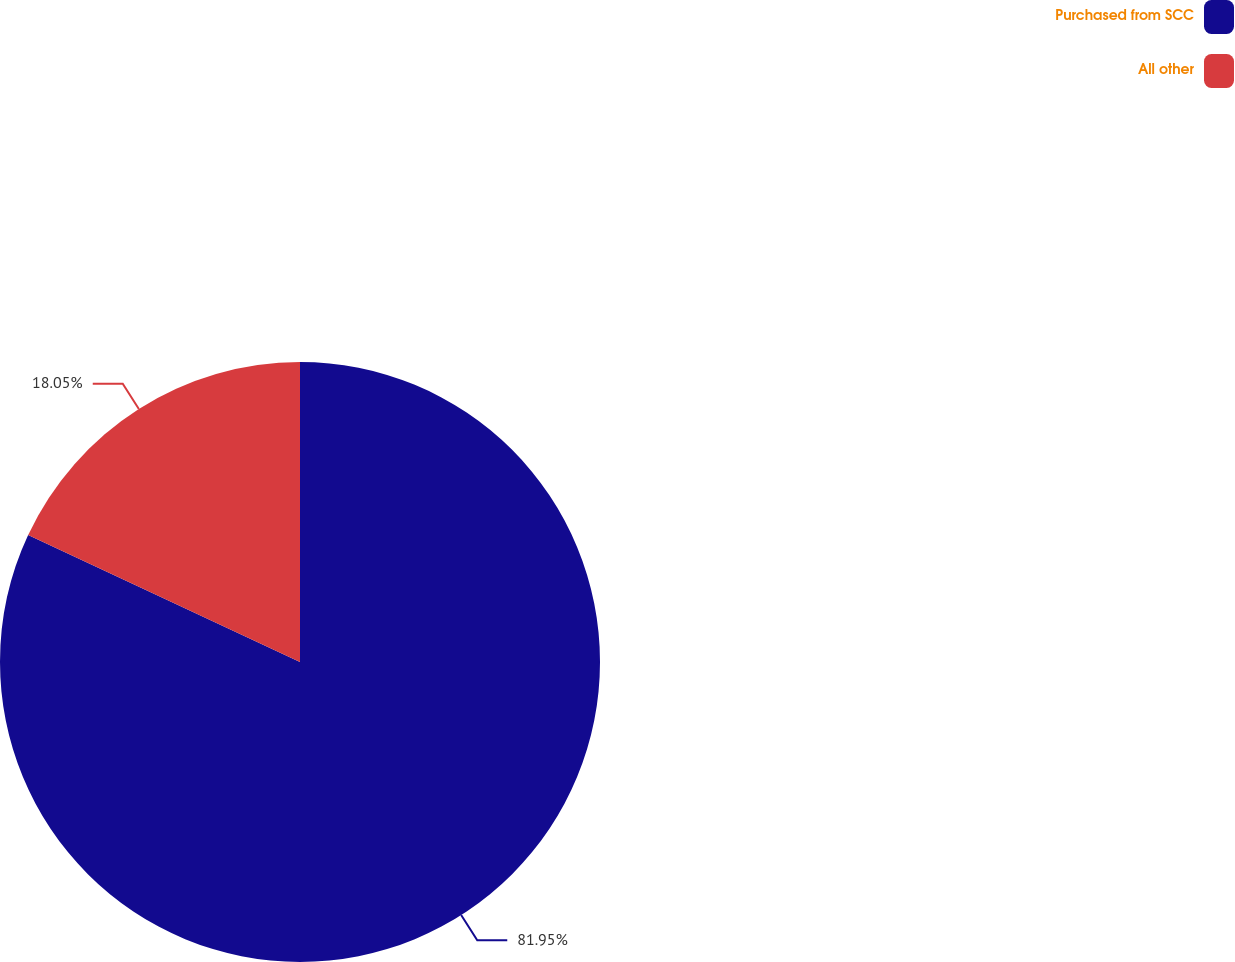<chart> <loc_0><loc_0><loc_500><loc_500><pie_chart><fcel>Purchased from SCC<fcel>All other<nl><fcel>81.95%<fcel>18.05%<nl></chart> 